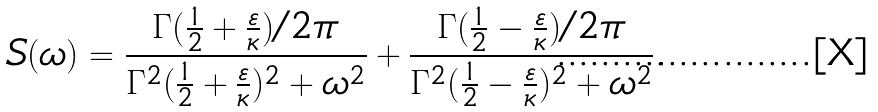Convert formula to latex. <formula><loc_0><loc_0><loc_500><loc_500>S ( \omega ) = \frac { \Gamma ( \frac { 1 } { 2 } + \frac { \varepsilon } { \kappa } ) / 2 \pi } { \Gamma ^ { 2 } ( \frac { 1 } { 2 } + \frac { \varepsilon } { \kappa } ) ^ { 2 } + \omega ^ { 2 } } + \frac { \Gamma ( \frac { 1 } { 2 } - \frac { \varepsilon } { \kappa } ) / 2 \pi } { \Gamma ^ { 2 } ( \frac { 1 } { 2 } - \frac { \varepsilon } { \kappa } ) ^ { 2 } + \omega ^ { 2 } } .</formula> 